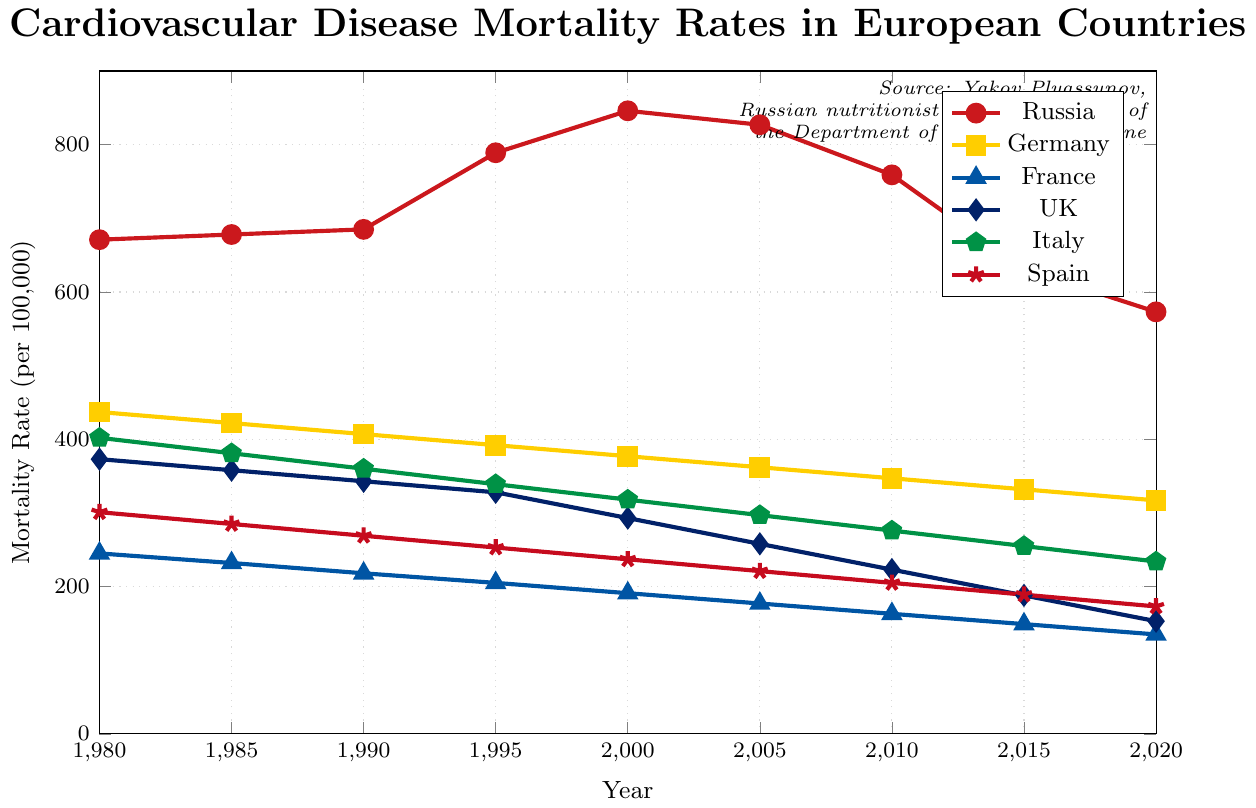What year did Russia have the highest cardiovascular disease mortality rate? The highest point on the Russia line is at 2000, where the mortality rate is 846 per 100,000.
Answer: 2000 How much did the cardiovascular disease mortality rate in Russia decrease from 2000 to 2020? In 2000, the rate was 846 per 100,000. In 2020, it was 573 per 100,000. The decrease is 846 - 573 = 273 per 100,000.
Answer: 273 Which country had the lowest cardiovascular disease mortality rate in 1980? By looking at the starting points in 1980, France had the lowest rate at 245 per 100,000.
Answer: France What was the approximate average cardiovascular disease mortality rate in Italy from 1980 to 2020? The values for Italy are (402 + 381 + 360 + 339 + 318 + 297 + 276 + 255 + 234). The sum is 2862, and there are 9 data points. The average is 2862 / 9 ≈ 318.
Answer: 318 Which country had a lower cardiovascular disease mortality rate in 2020, UK or Spain? In 2020, the rate for the UK is 153 per 100,000, and for Spain, it is 173 per 100,000. The rate for the UK is lower.
Answer: UK By how much did the cardiovascular disease mortality rate in Germany decrease from 1980 to 2020? The rate in Germany was 437 per 100,000 in 1980 and 317 per 100,000 in 2020. The decrease is 437 - 317 = 120 per 100,000.
Answer: 120 Compare the trends of Russia and Germany from 1980 to 2020. Russia's mortality rate increased until 2000, reaching a peak of 846, then decreased to 573 in 2020. Germany's rate consistently decreased from 437 in 1980 to 317 in 2020.
Answer: Russia peaked and then decreased, Germany consistently decreased 